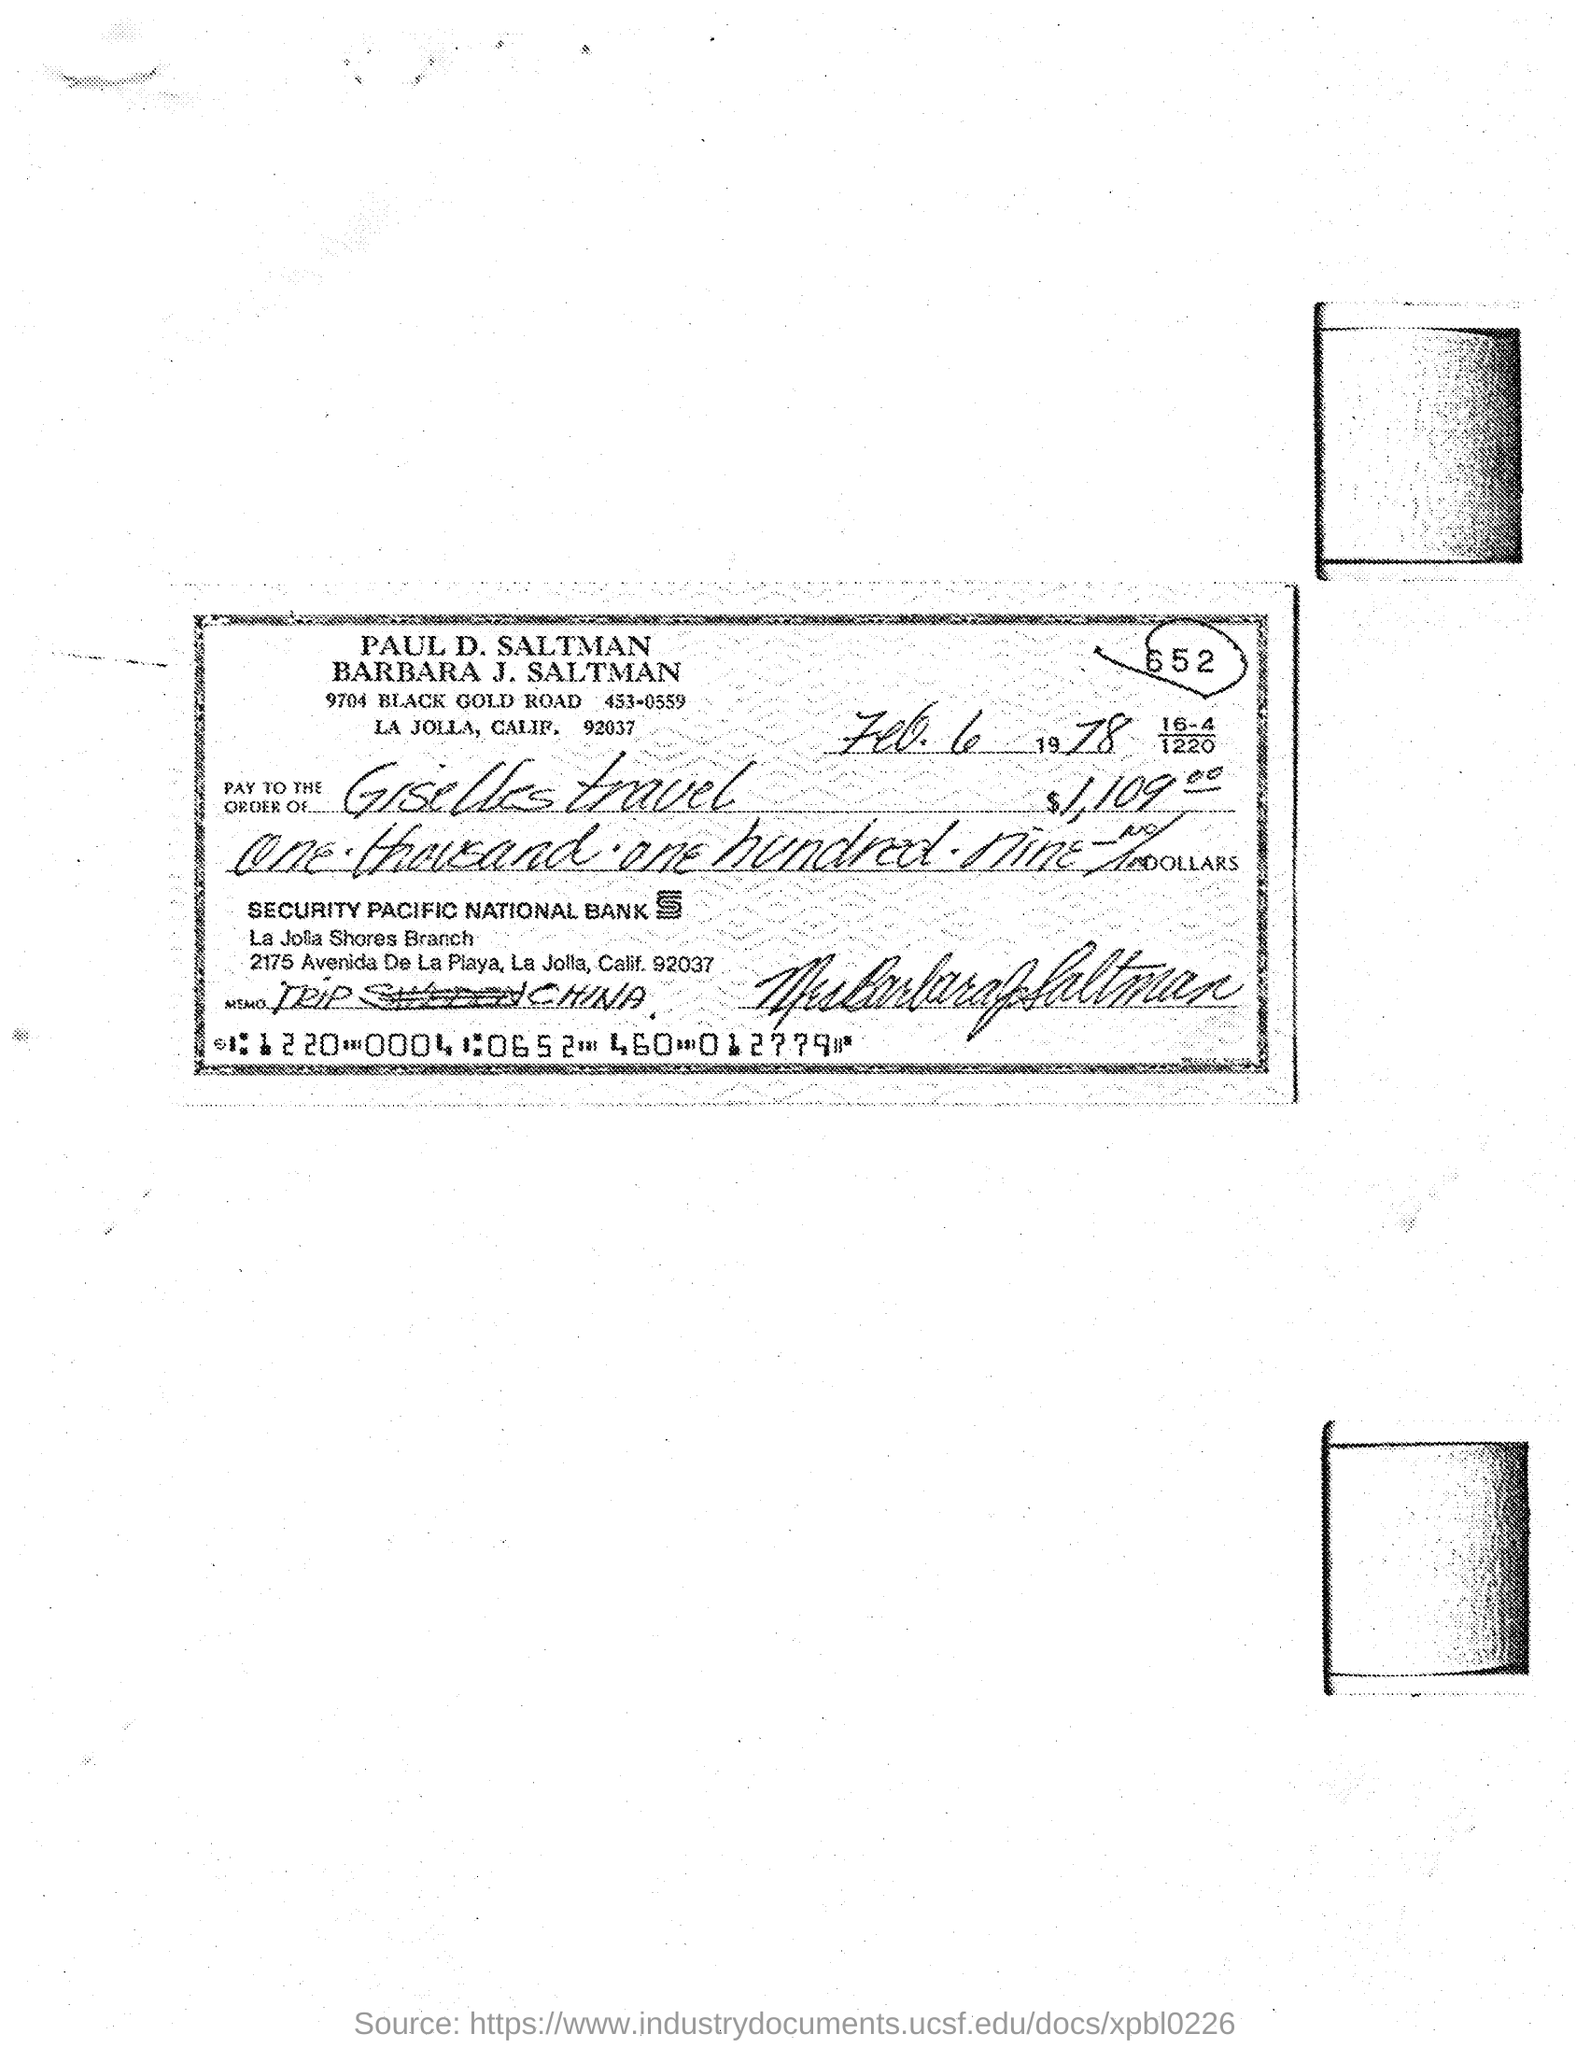Point out several critical features in this image. The date of the cheque is February 6, 1978. 